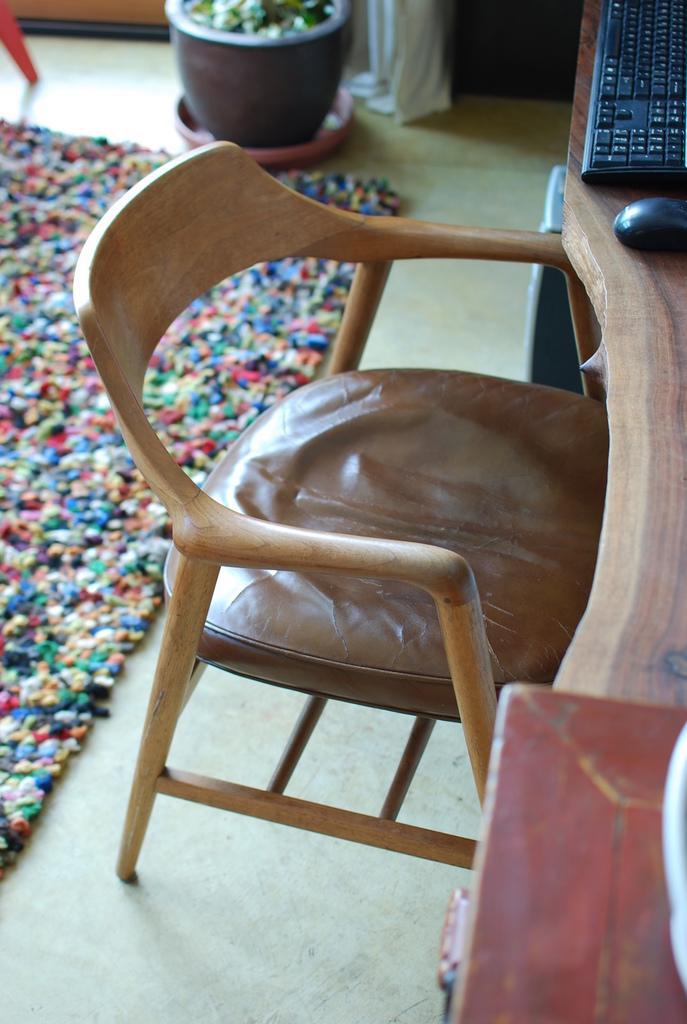Can you describe this image briefly? In this image there is a chair, in front of the chair there is a keyboard, mouse and some objects on the table, beside the chair there is a CPU, behind the chair there is a mat on the floor, in front off the mat there is a flower pot, behind the flower pot there is a curtain and the leg of a chair. 